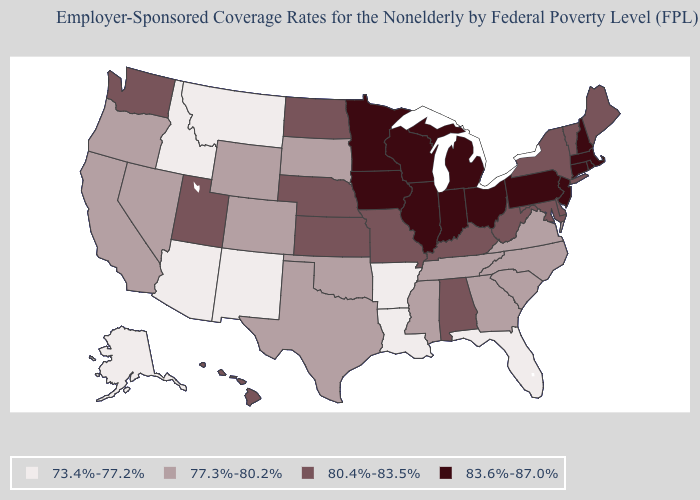What is the value of Kentucky?
Keep it brief. 80.4%-83.5%. Name the states that have a value in the range 73.4%-77.2%?
Keep it brief. Alaska, Arizona, Arkansas, Florida, Idaho, Louisiana, Montana, New Mexico. What is the value of Hawaii?
Give a very brief answer. 80.4%-83.5%. What is the value of California?
Answer briefly. 77.3%-80.2%. Name the states that have a value in the range 83.6%-87.0%?
Write a very short answer. Connecticut, Illinois, Indiana, Iowa, Massachusetts, Michigan, Minnesota, New Hampshire, New Jersey, Ohio, Pennsylvania, Rhode Island, Wisconsin. What is the lowest value in states that border Wisconsin?
Keep it brief. 83.6%-87.0%. What is the value of New Mexico?
Quick response, please. 73.4%-77.2%. Among the states that border Alabama , which have the highest value?
Give a very brief answer. Georgia, Mississippi, Tennessee. Name the states that have a value in the range 80.4%-83.5%?
Quick response, please. Alabama, Delaware, Hawaii, Kansas, Kentucky, Maine, Maryland, Missouri, Nebraska, New York, North Dakota, Utah, Vermont, Washington, West Virginia. What is the lowest value in the South?
Answer briefly. 73.4%-77.2%. What is the lowest value in states that border Arizona?
Write a very short answer. 73.4%-77.2%. What is the highest value in states that border Vermont?
Answer briefly. 83.6%-87.0%. What is the highest value in the USA?
Quick response, please. 83.6%-87.0%. Name the states that have a value in the range 80.4%-83.5%?
Give a very brief answer. Alabama, Delaware, Hawaii, Kansas, Kentucky, Maine, Maryland, Missouri, Nebraska, New York, North Dakota, Utah, Vermont, Washington, West Virginia. Which states have the highest value in the USA?
Keep it brief. Connecticut, Illinois, Indiana, Iowa, Massachusetts, Michigan, Minnesota, New Hampshire, New Jersey, Ohio, Pennsylvania, Rhode Island, Wisconsin. 